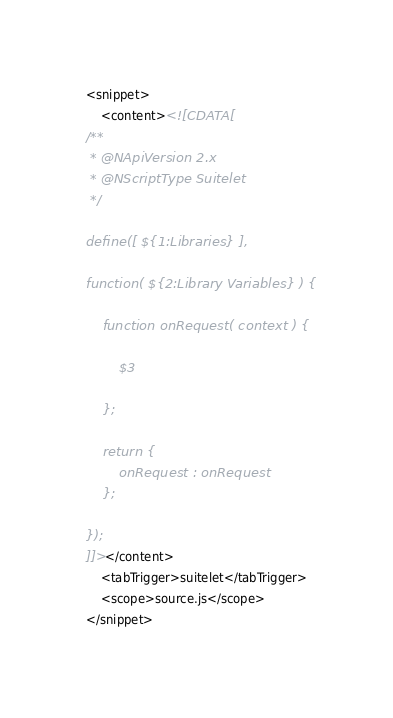Convert code to text. <code><loc_0><loc_0><loc_500><loc_500><_XML_><snippet>
	<content><![CDATA[
/**
 * @NApiVersion 2.x
 * @NScriptType Suitelet
 */

define([ ${1:Libraries} ],

function( ${2:Library Variables} ) {

	function onRequest( context ) {

		$3

	};

	return {
		onRequest : onRequest
	};

});
]]></content>
	<tabTrigger>suitelet</tabTrigger>
	<scope>source.js</scope>
</snippet></code> 